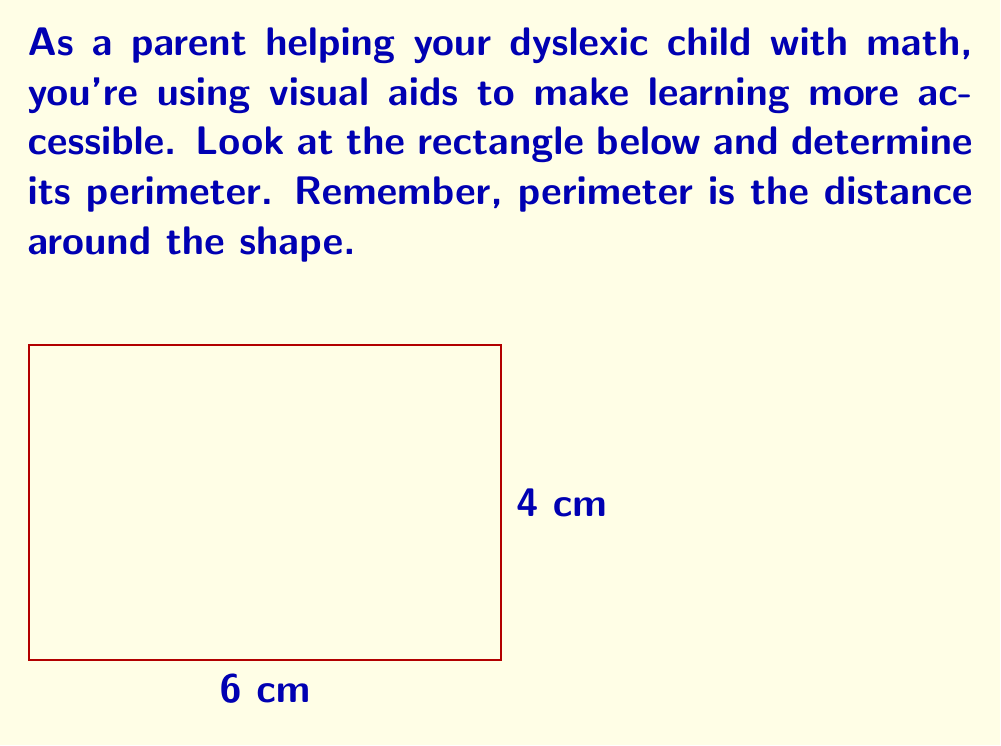Provide a solution to this math problem. Let's break this down step-by-step:

1. Identify the shape: We have a rectangle.

2. Recall the formula for perimeter of a rectangle:
   $$ P = 2l + 2w $$
   where $P$ is perimeter, $l$ is length, and $w$ is width.

3. Identify the dimensions:
   - Length (l) = 6 cm
   - Width (w) = 4 cm

4. Plug these values into the formula:
   $$ P = 2(6) + 2(4) $$

5. Multiply:
   $$ P = 12 + 8 $$

6. Add:
   $$ P = 20 $$

Therefore, the perimeter of the rectangle is 20 cm.
Answer: 20 cm 